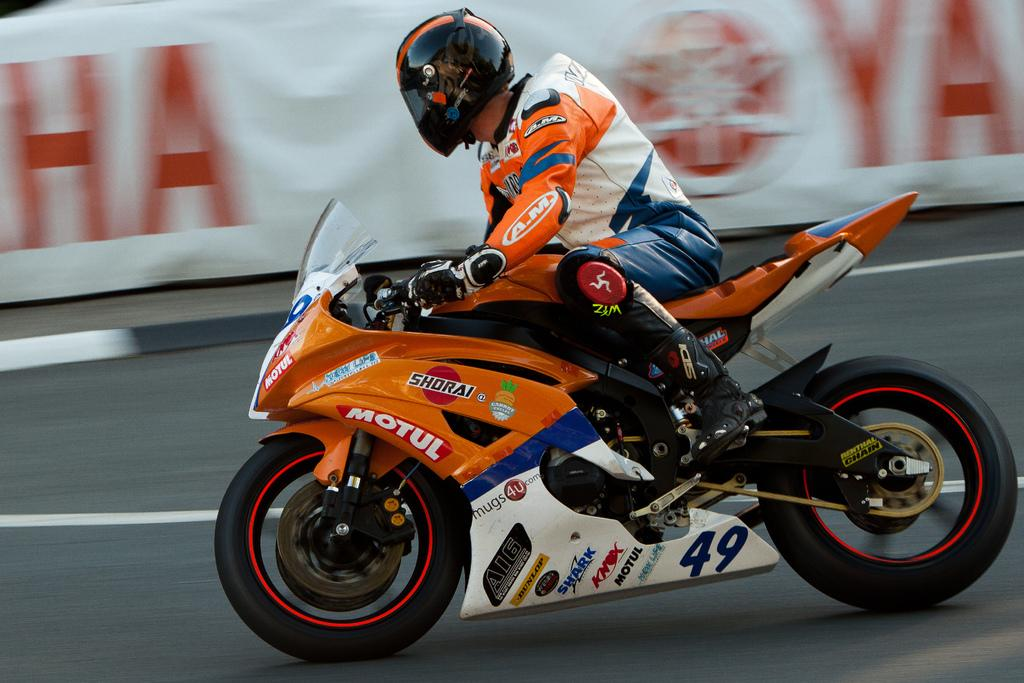What is the person in the image doing? The person is sitting on a bike in the image. What type of clothing is the person wearing? The person is wearing a jacket and a helmet. What can be seen in the background of the image? There is a banner in the background of the image. How would you describe the background of the image? The background of the image is blurred. What type of shoe is the person wearing in the image? There is no information about the person's shoes in the image, so we cannot determine the type of shoe they are wearing. How many clovers can be seen in the image? There are no clovers present in the image. 